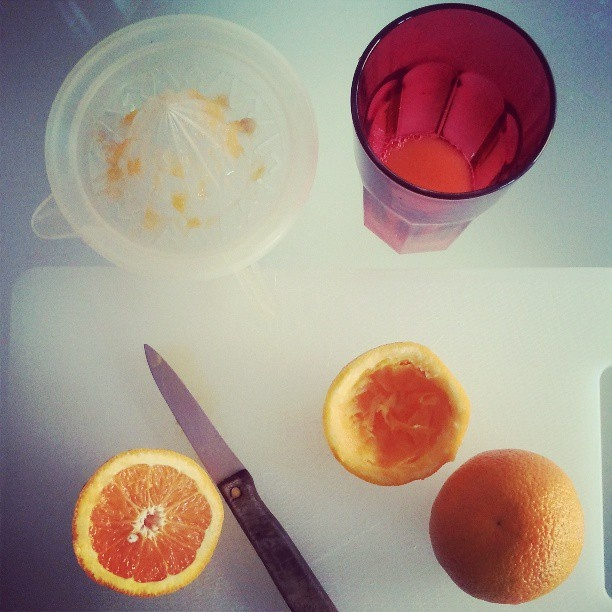Describe the objects in this image and their specific colors. I can see dining table in purple, darkgray, beige, and gray tones, cup in purple, maroon, brown, darkgray, and black tones, orange in purple, maroon, brown, and tan tones, orange in purple, tan, red, khaki, and brown tones, and orange in purple, brown, tan, and khaki tones in this image. 